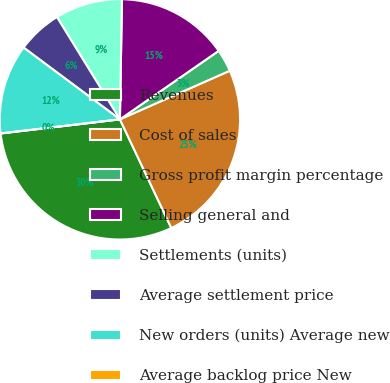<chart> <loc_0><loc_0><loc_500><loc_500><pie_chart><fcel>Revenues<fcel>Cost of sales<fcel>Gross profit margin percentage<fcel>Selling general and<fcel>Settlements (units)<fcel>Average settlement price<fcel>New orders (units) Average new<fcel>Average backlog price New<nl><fcel>30.16%<fcel>24.6%<fcel>3.02%<fcel>15.08%<fcel>9.05%<fcel>6.03%<fcel>12.06%<fcel>0.0%<nl></chart> 